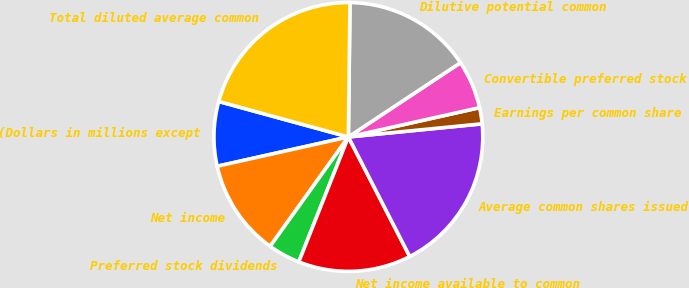Convert chart. <chart><loc_0><loc_0><loc_500><loc_500><pie_chart><fcel>(Dollars in millions except<fcel>Net income<fcel>Preferred stock dividends<fcel>Net income available to common<fcel>Average common shares issued<fcel>Earnings per common share<fcel>Convertible preferred stock<fcel>Dilutive potential common<fcel>Total diluted average common<nl><fcel>7.75%<fcel>11.62%<fcel>3.87%<fcel>13.56%<fcel>19.01%<fcel>1.94%<fcel>5.81%<fcel>15.5%<fcel>20.94%<nl></chart> 